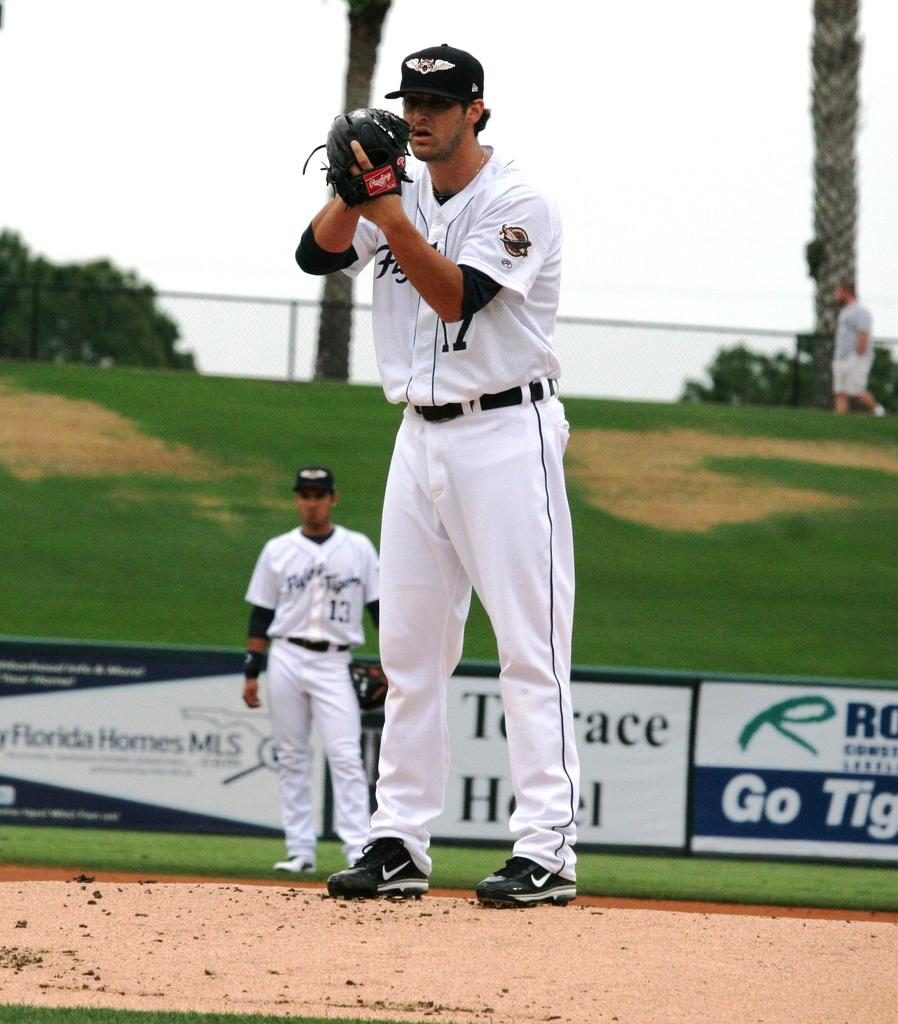<image>
Provide a brief description of the given image. a baseball team pticher wearing white and the number 17 on the mound ready to throw the ball 